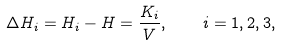Convert formula to latex. <formula><loc_0><loc_0><loc_500><loc_500>\Delta H _ { i } = H _ { i } - H = \frac { K _ { i } } { V } , \quad i = 1 , 2 , 3 ,</formula> 